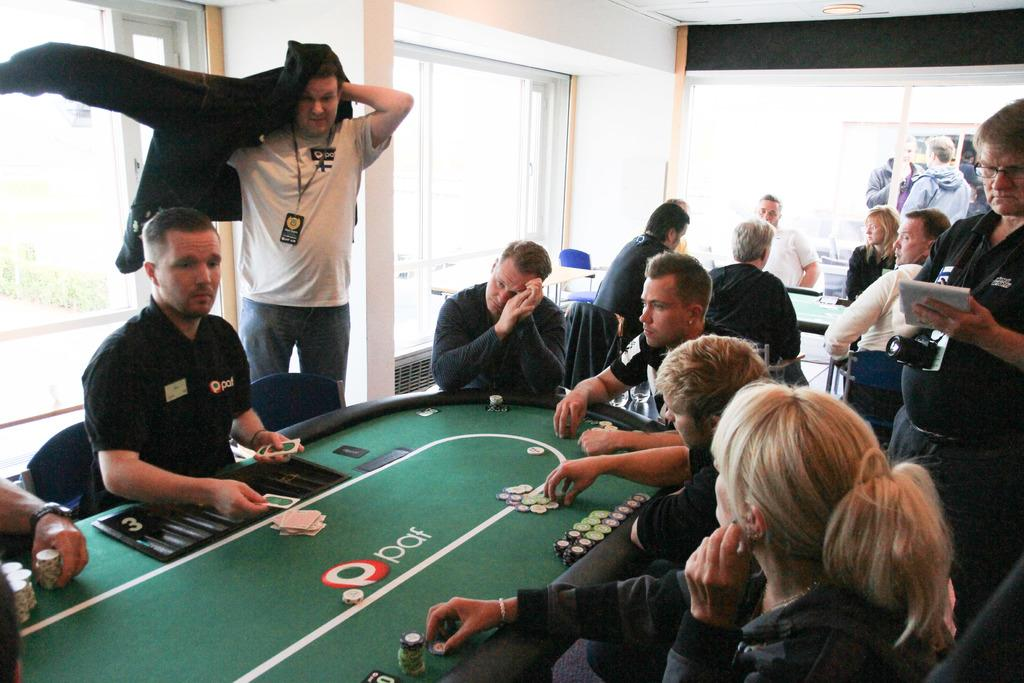Who or what is present in the image? There are people in the image. What objects are in the image that might be used for sitting? There are chairs in the image. What type of items can be seen that might be used for playing games? Game boards, coins, and playing cards are present in the image. What can be seen in the background of the image? There is a wall and glass windows in the background of the image. What type of fowl can be seen interacting with the playing cards in the image? There is no fowl present in the image; it features people playing games with game boards, coins, and playing cards. Can you describe the stranger in the image? There is no stranger present in the image; it features people who are presumably familiar with each other. 